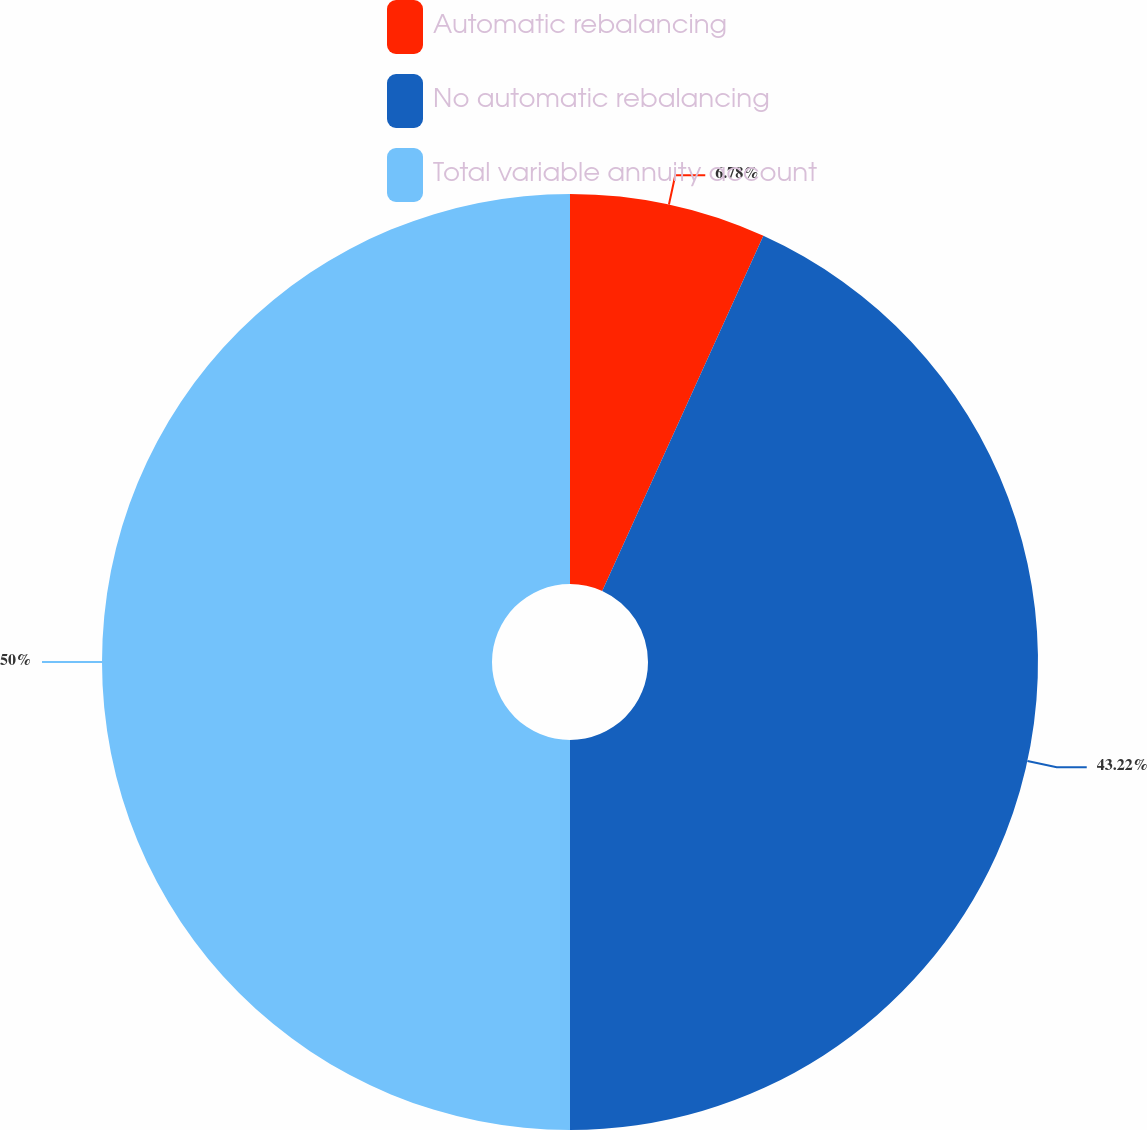Convert chart to OTSL. <chart><loc_0><loc_0><loc_500><loc_500><pie_chart><fcel>Automatic rebalancing<fcel>No automatic rebalancing<fcel>Total variable annuity account<nl><fcel>6.78%<fcel>43.22%<fcel>50.0%<nl></chart> 